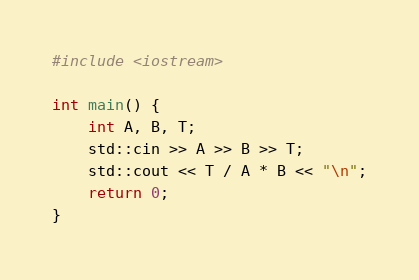Convert code to text. <code><loc_0><loc_0><loc_500><loc_500><_C++_>#include <iostream>

int main() {
    int A, B, T;
    std::cin >> A >> B >> T;
    std::cout << T / A * B << "\n";
    return 0;
}
</code> 